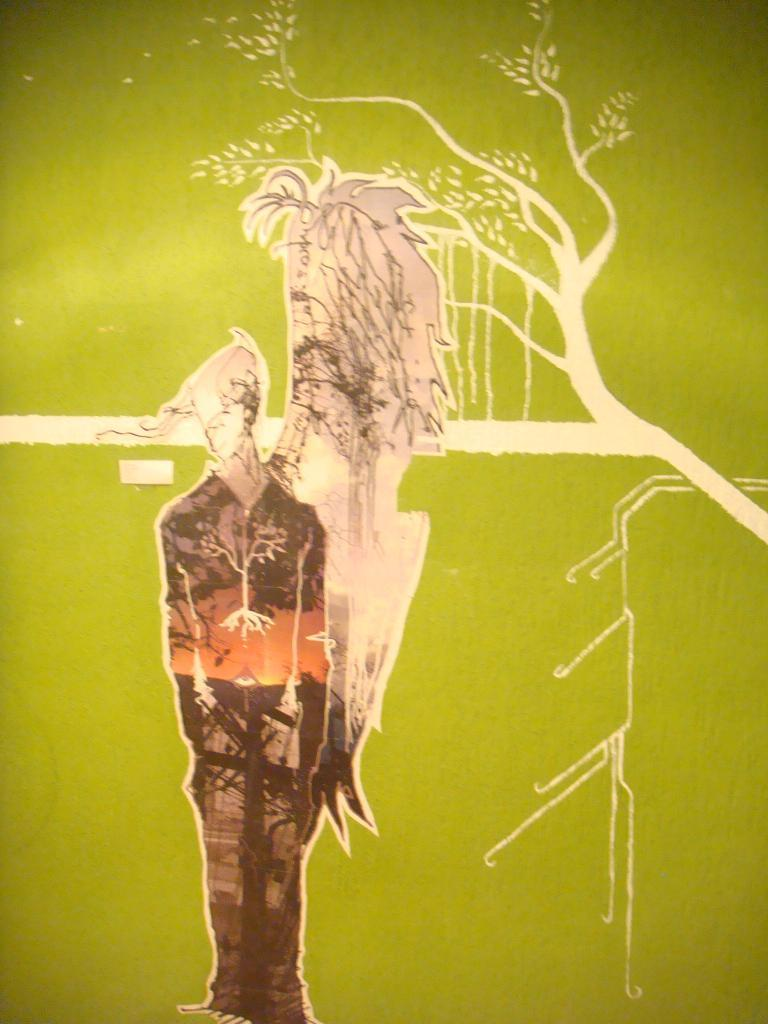What is the color of the object in the image? The object in the image has a green color. What can be found on the green object? There is art on the green object. Is there a bear moving around in the image? No, there is no bear present in the image. 